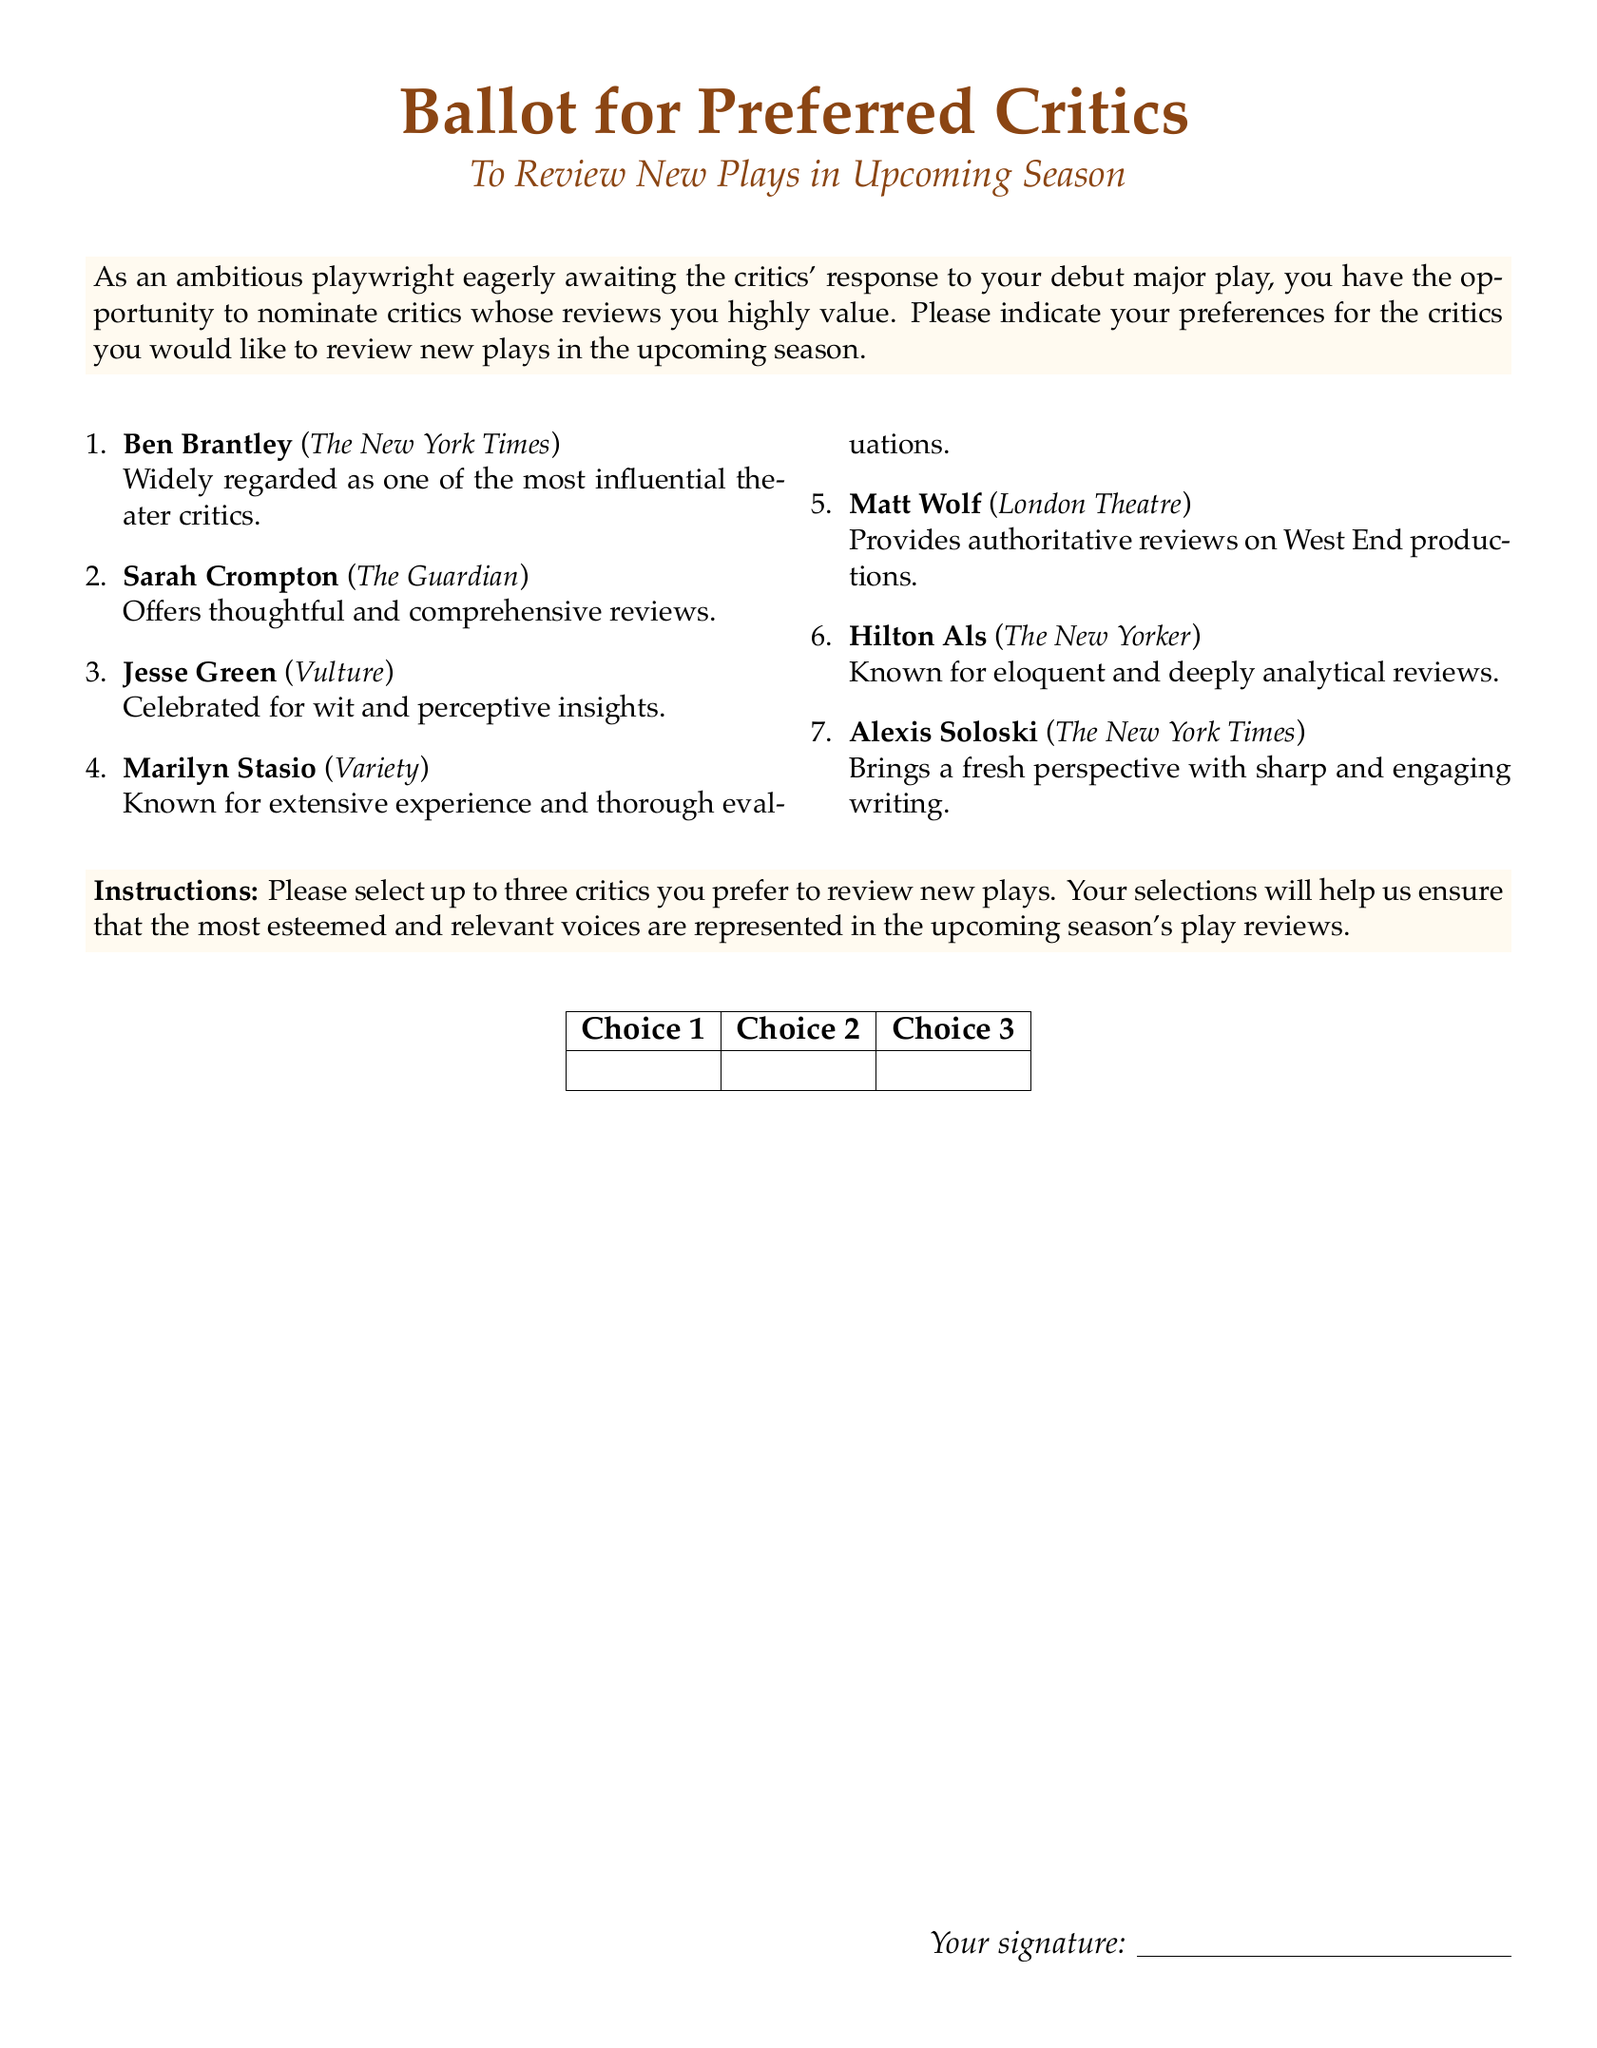What is the title of the document? The title is prominently displayed at the top and indicates the purpose of the document, which is to gather preferences for critics.
Answer: Ballot for Preferred Critics Who is the first critic listed on the ballot? The first critic is always displayed at the top of the list, making it easy to identify.
Answer: Ben Brantley How many critics can be selected on the ballot? The instructions clearly state the maximum number of selections allowed for filling out the ballot.
Answer: Three Which publication is associated with Sarah Crompton? The critic's associated publication is mentioned in parentheses next to their name, providing context.
Answer: The Guardian What color is used for the title? The title color is defined in the document, creating a distinct visual appearance.
Answer: RGB(139,69,19) What is the purpose of this document? The purpose is specifically outlined in the introduction, summarizing the intention of the ballot.
Answer: To review new plays in the upcoming season Who is known for witty and perceptive insights? The phrase describing this critic helps identify their writing style and reputation.
Answer: Jesse Green What does the table in the document represent? The layout of the table suggests its function within the context of the ballot, facilitating selections.
Answer: Choices for critics What is the signature line for? The signature line is a common feature in ballots, indicating its purpose for the signer.
Answer: To validate the submission 